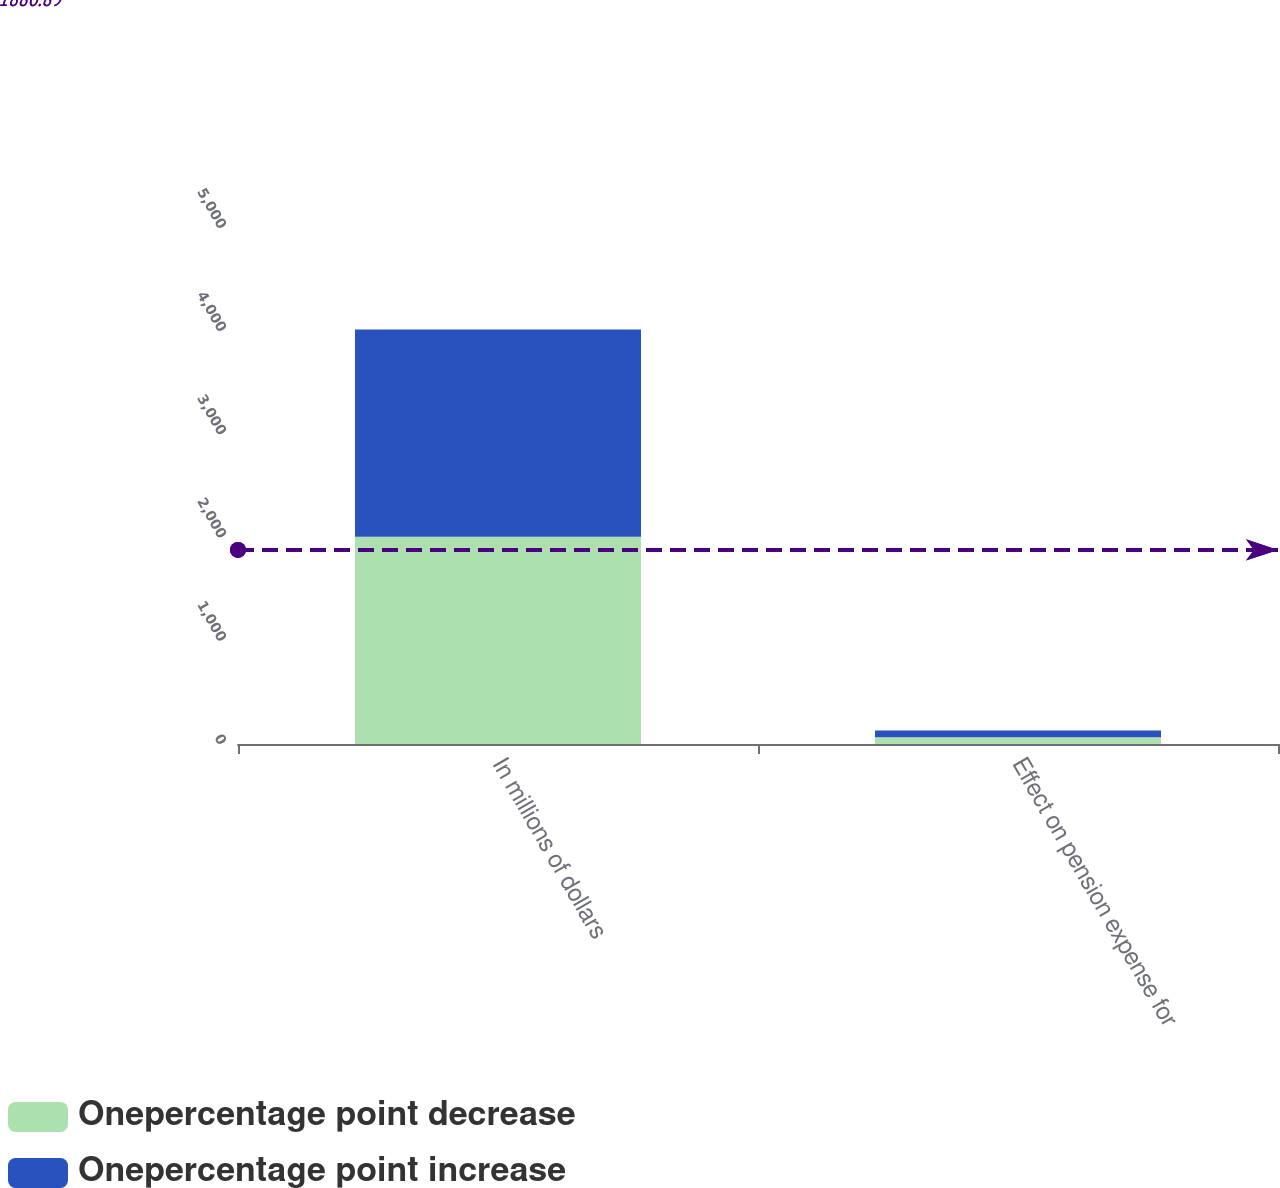<chart> <loc_0><loc_0><loc_500><loc_500><stacked_bar_chart><ecel><fcel>In millions of dollars<fcel>Effect on pension expense for<nl><fcel>Onepercentage point decrease<fcel>2008<fcel>66<nl><fcel>Onepercentage point increase<fcel>2008<fcel>66<nl></chart> 